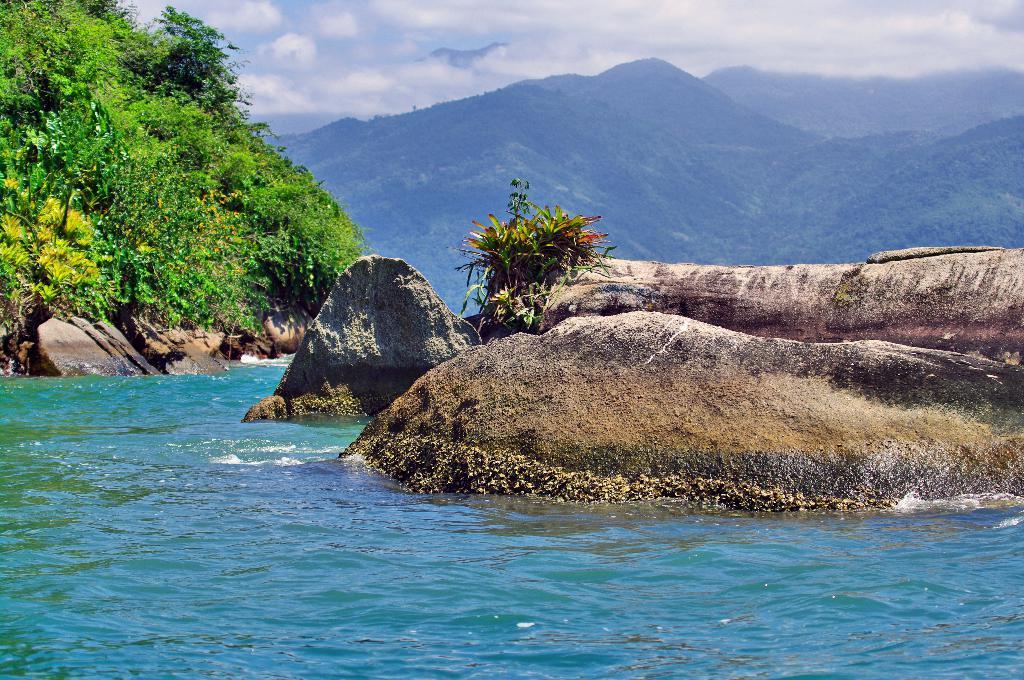Describe this image in one or two sentences. In this image we can see a water body, a group of plants and the rock. On the backside we can see a group of trees on the hills and the sky which looks cloudy. 